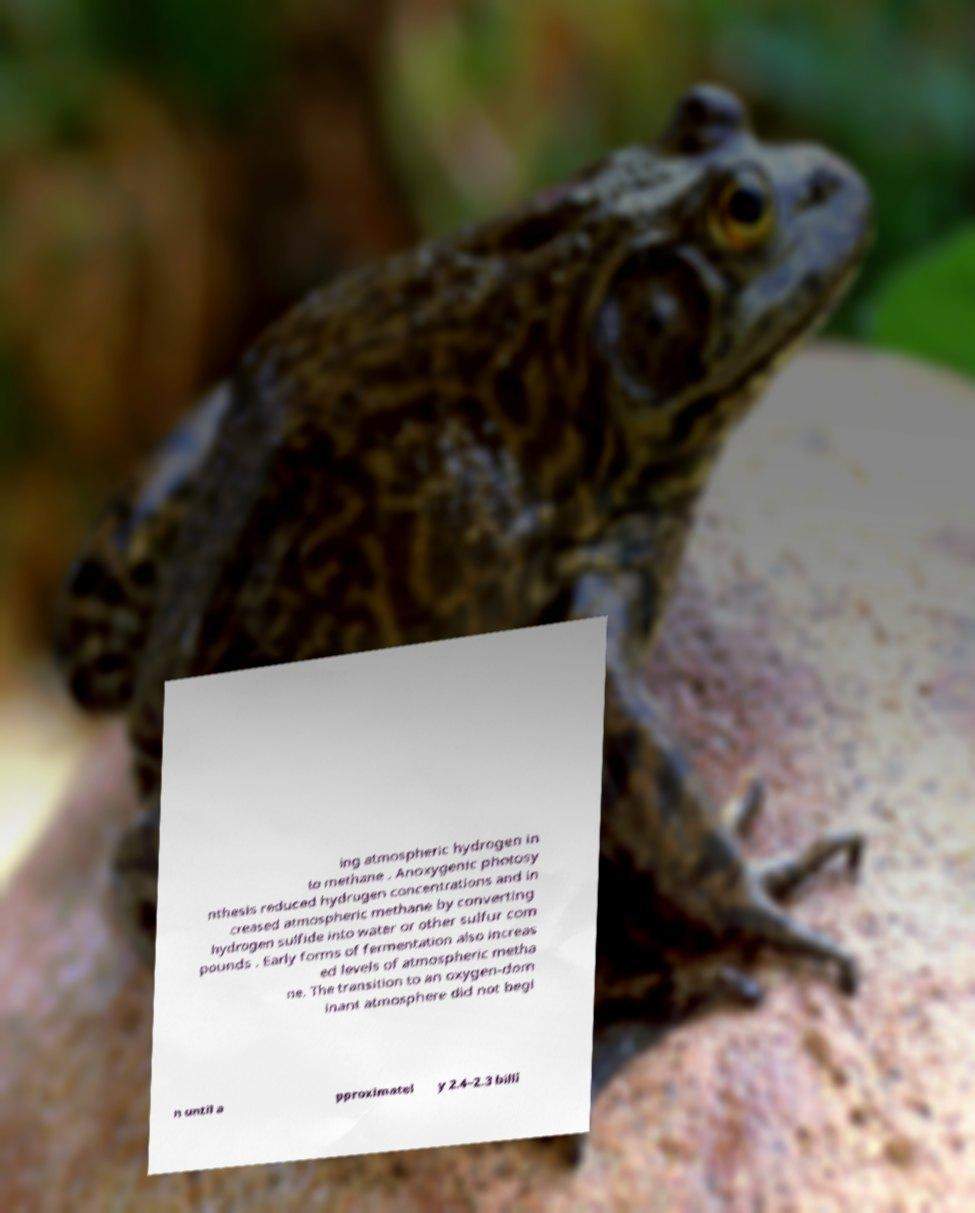What messages or text are displayed in this image? I need them in a readable, typed format. ing atmospheric hydrogen in to methane . Anoxygenic photosy nthesis reduced hydrogen concentrations and in creased atmospheric methane by converting hydrogen sulfide into water or other sulfur com pounds . Early forms of fermentation also increas ed levels of atmospheric metha ne. The transition to an oxygen-dom inant atmosphere did not begi n until a pproximatel y 2.4–2.3 billi 